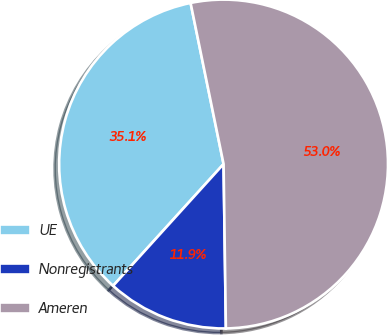Convert chart. <chart><loc_0><loc_0><loc_500><loc_500><pie_chart><fcel>UE<fcel>Nonregistrants<fcel>Ameren<nl><fcel>35.06%<fcel>11.95%<fcel>52.99%<nl></chart> 